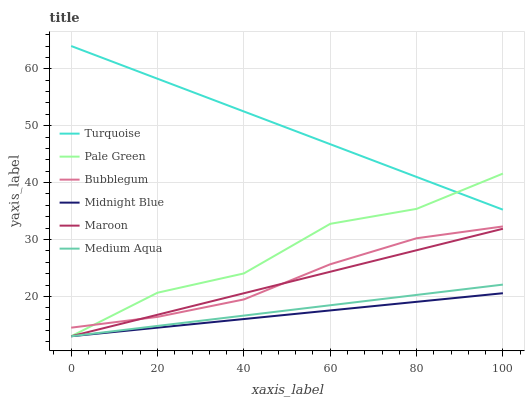Does Midnight Blue have the minimum area under the curve?
Answer yes or no. Yes. Does Turquoise have the maximum area under the curve?
Answer yes or no. Yes. Does Maroon have the minimum area under the curve?
Answer yes or no. No. Does Maroon have the maximum area under the curve?
Answer yes or no. No. Is Midnight Blue the smoothest?
Answer yes or no. Yes. Is Pale Green the roughest?
Answer yes or no. Yes. Is Maroon the smoothest?
Answer yes or no. No. Is Maroon the roughest?
Answer yes or no. No. Does Midnight Blue have the lowest value?
Answer yes or no. Yes. Does Bubblegum have the lowest value?
Answer yes or no. No. Does Turquoise have the highest value?
Answer yes or no. Yes. Does Maroon have the highest value?
Answer yes or no. No. Is Medium Aqua less than Bubblegum?
Answer yes or no. Yes. Is Turquoise greater than Medium Aqua?
Answer yes or no. Yes. Does Medium Aqua intersect Maroon?
Answer yes or no. Yes. Is Medium Aqua less than Maroon?
Answer yes or no. No. Is Medium Aqua greater than Maroon?
Answer yes or no. No. Does Medium Aqua intersect Bubblegum?
Answer yes or no. No. 